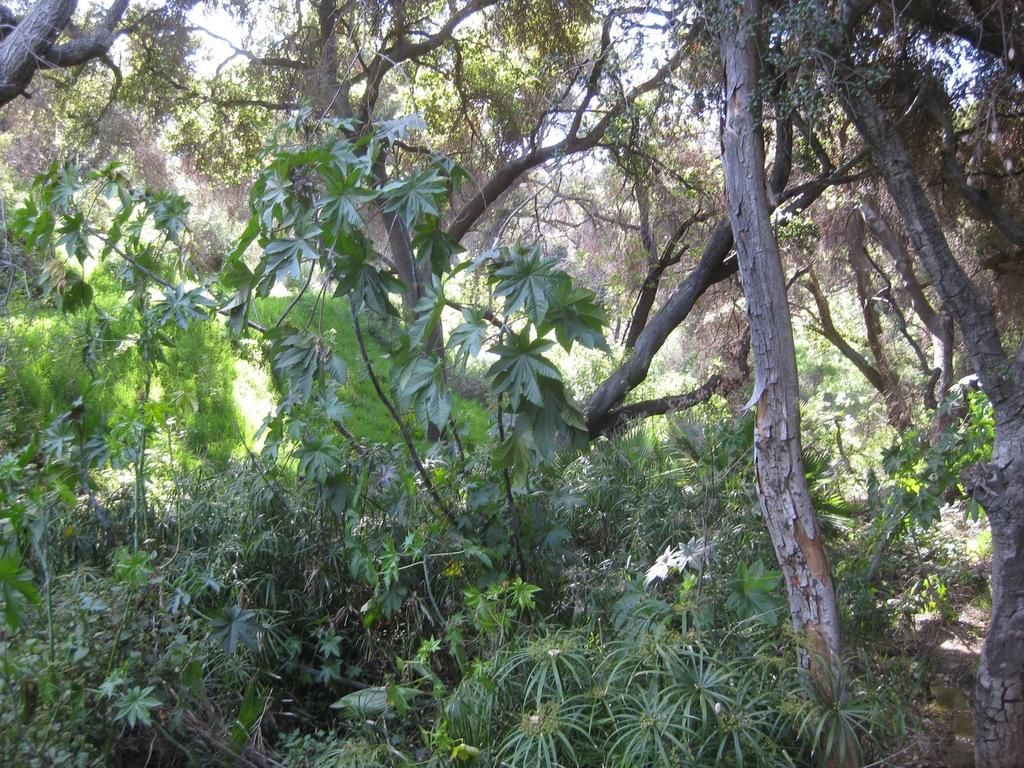What is the main subject of the image? The main subject of the image is many trees in the center. Can you describe the trees in the image? Unfortunately, the provided facts do not give any details about the trees, so we cannot describe them further. What decision did the trees make in the image? Trees do not make decisions, as they are inanimate objects. 